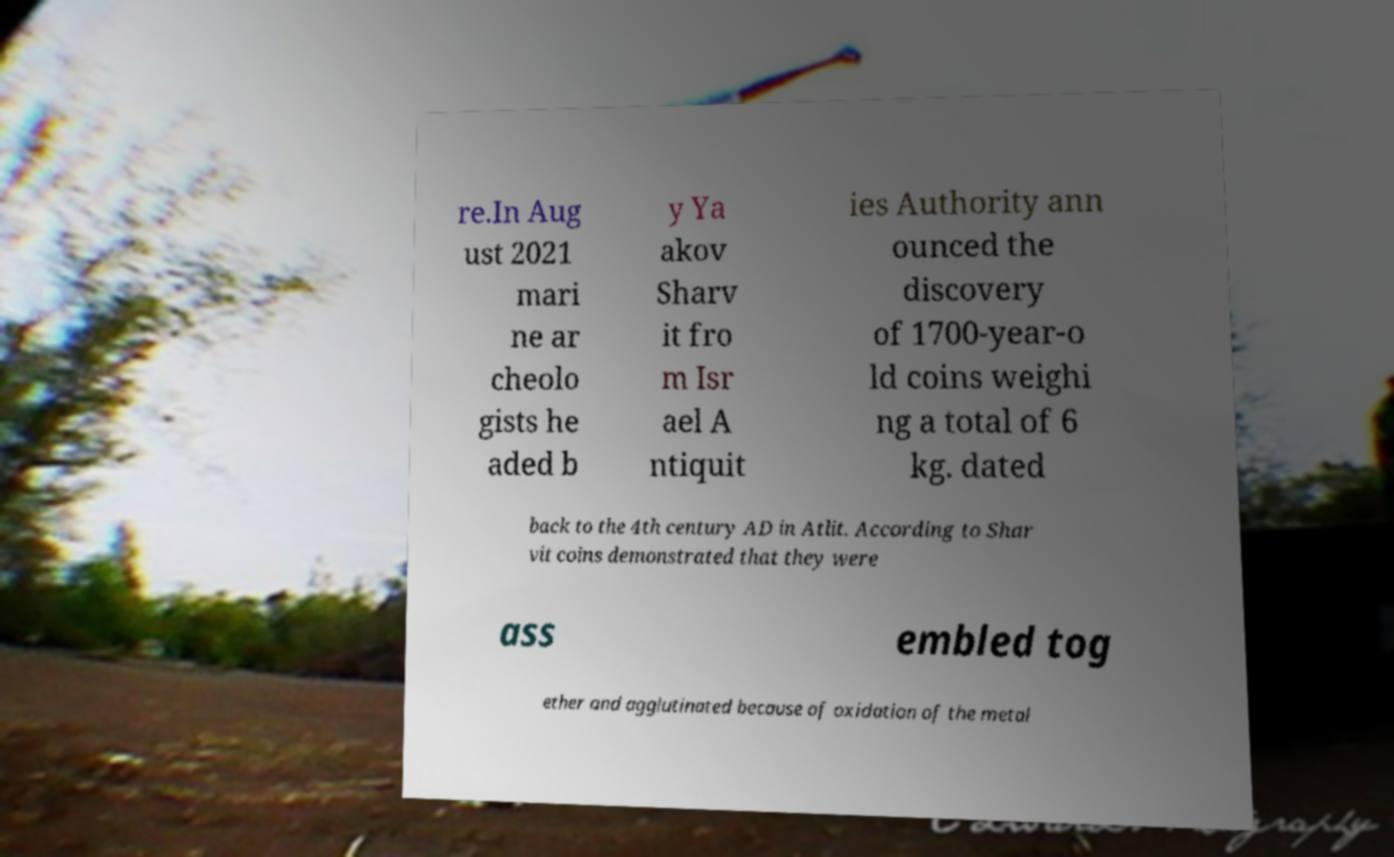Please identify and transcribe the text found in this image. re.In Aug ust 2021 mari ne ar cheolo gists he aded b y Ya akov Sharv it fro m Isr ael A ntiquit ies Authority ann ounced the discovery of 1700-year-o ld coins weighi ng a total of 6 kg. dated back to the 4th century AD in Atlit. According to Shar vit coins demonstrated that they were ass embled tog ether and agglutinated because of oxidation of the metal 